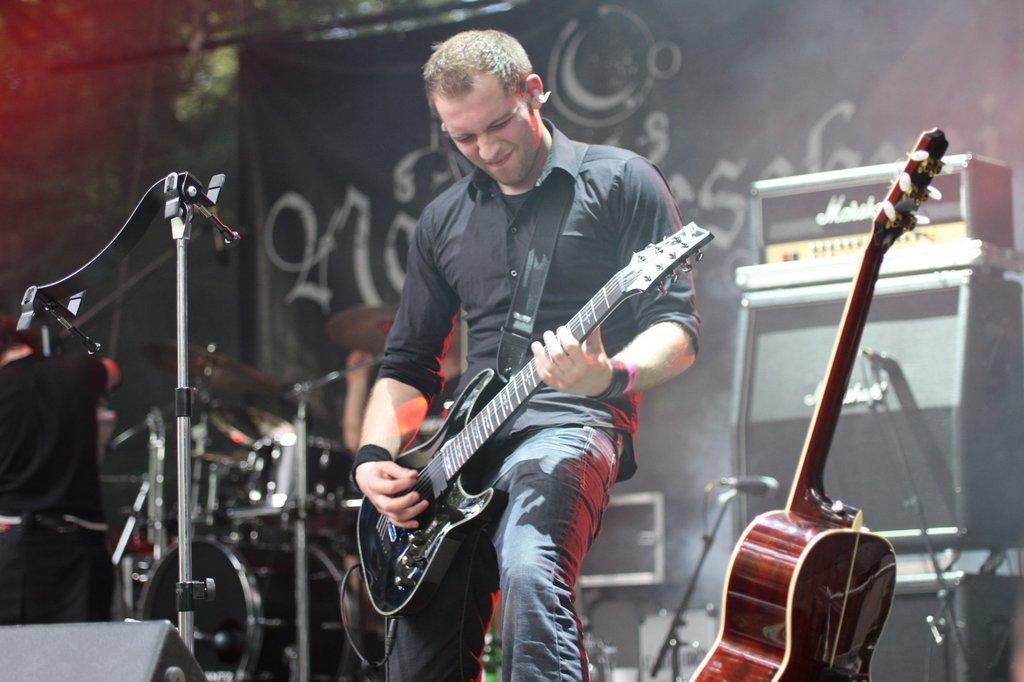Please provide a concise description of this image. This picture shows a man standing and playing a guitar in his hands in front of a mic and a stand. There is a guitar in the right side. In the background there are some speakers and drums here. We can observe a poster in the black color here. 